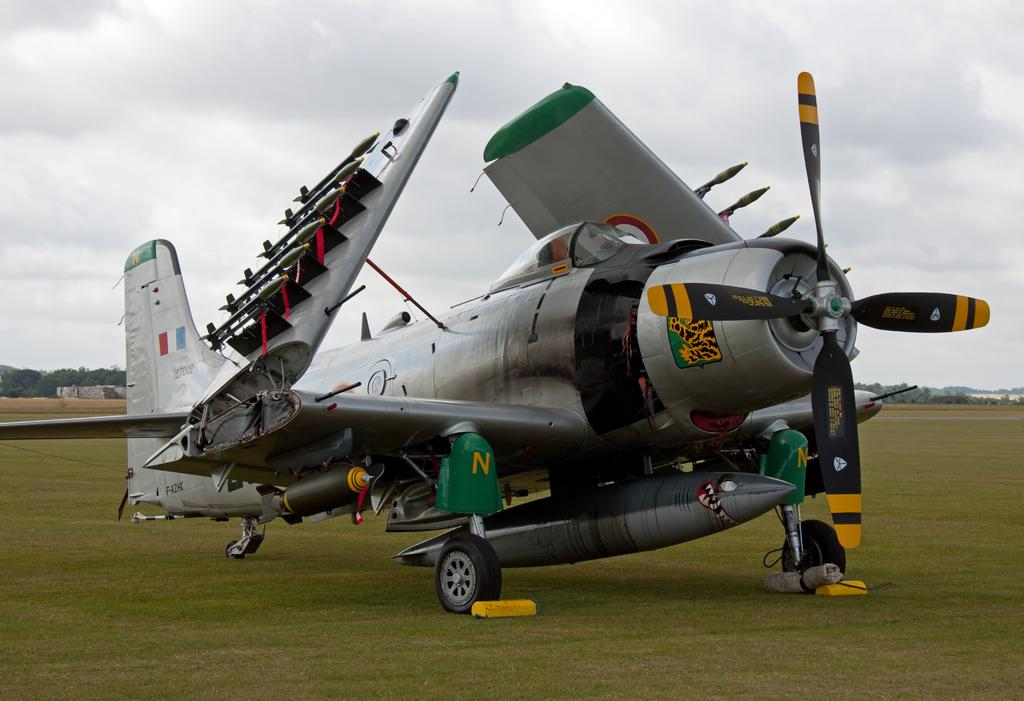What is the setting of the image? The image is an outside view. What can be seen in the middle of the image? There is an aircraft on the ground in the middle of the image. What type of vegetation is visible in the background of the image? There are trees in the background of the image. What is visible at the top of the image? The sky is visible at the top of the image, and clouds are present in the sky. How many ants can be seen carrying the bike in the image? There are no ants or bikes present in the image. 